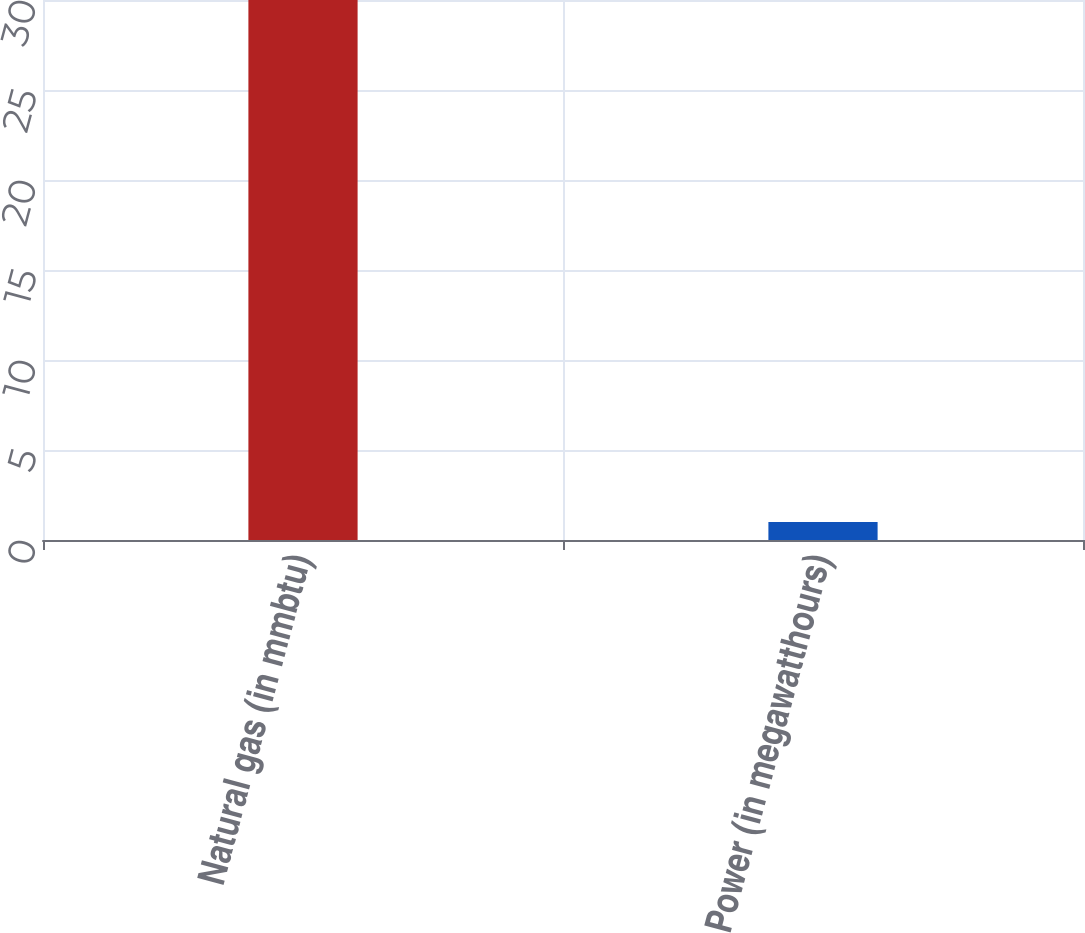Convert chart to OTSL. <chart><loc_0><loc_0><loc_500><loc_500><bar_chart><fcel>Natural gas (in mmbtu)<fcel>Power (in megawatthours)<nl><fcel>30<fcel>1<nl></chart> 